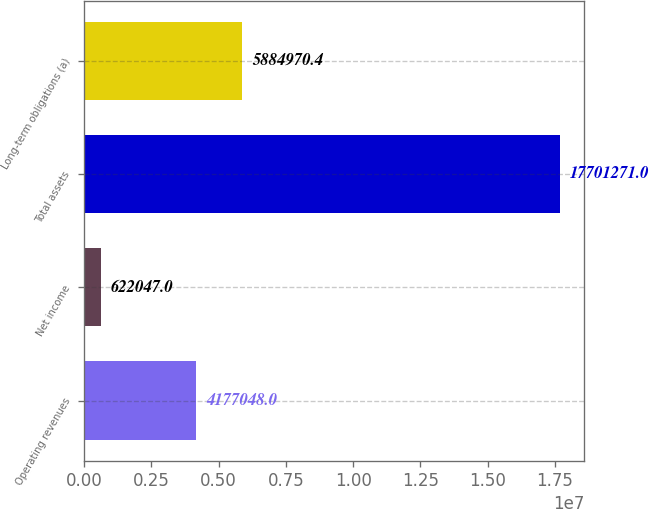<chart> <loc_0><loc_0><loc_500><loc_500><bar_chart><fcel>Operating revenues<fcel>Net income<fcel>Total assets<fcel>Long-term obligations (a)<nl><fcel>4.17705e+06<fcel>622047<fcel>1.77013e+07<fcel>5.88497e+06<nl></chart> 